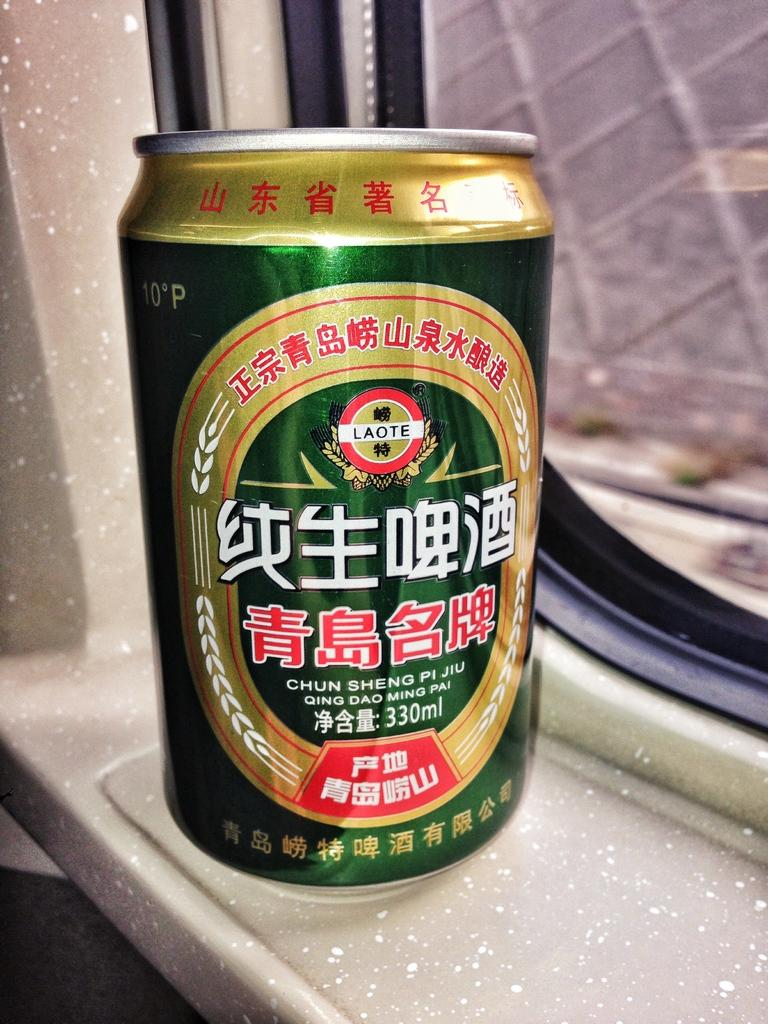What type of container is present in the image? There is a wine tin in the image. What color is the wine tin? The wine tin is green in color. Does the wine tin have any distinguishing features? Yes, the wine tin has a label. Where is the wine tin located in the image? The wine tin is placed near a window. What other item can be seen in the image? There is a glass in the image. Can you see a bridge connecting two buildings in the image? No, there is no bridge connecting two buildings in the image. Is there a whip or stick visible in the image? No, there is no whip or stick present in the image. 